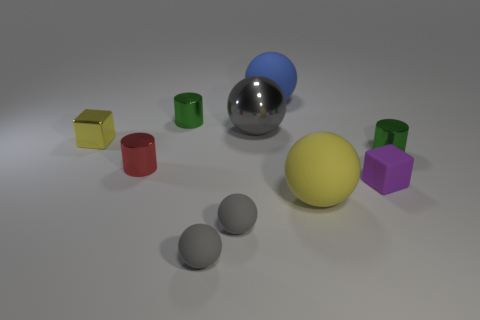How many gray spheres must be subtracted to get 1 gray spheres? 2 Subtract all red shiny cylinders. How many cylinders are left? 2 Subtract 1 cubes. How many cubes are left? 1 Subtract all big blue rubber things. Subtract all red cylinders. How many objects are left? 8 Add 1 tiny yellow metal things. How many tiny yellow metal things are left? 2 Add 4 metallic cubes. How many metallic cubes exist? 5 Subtract all yellow blocks. How many blocks are left? 1 Subtract 0 gray cylinders. How many objects are left? 10 Subtract all blocks. How many objects are left? 8 Subtract all green spheres. Subtract all cyan blocks. How many spheres are left? 5 